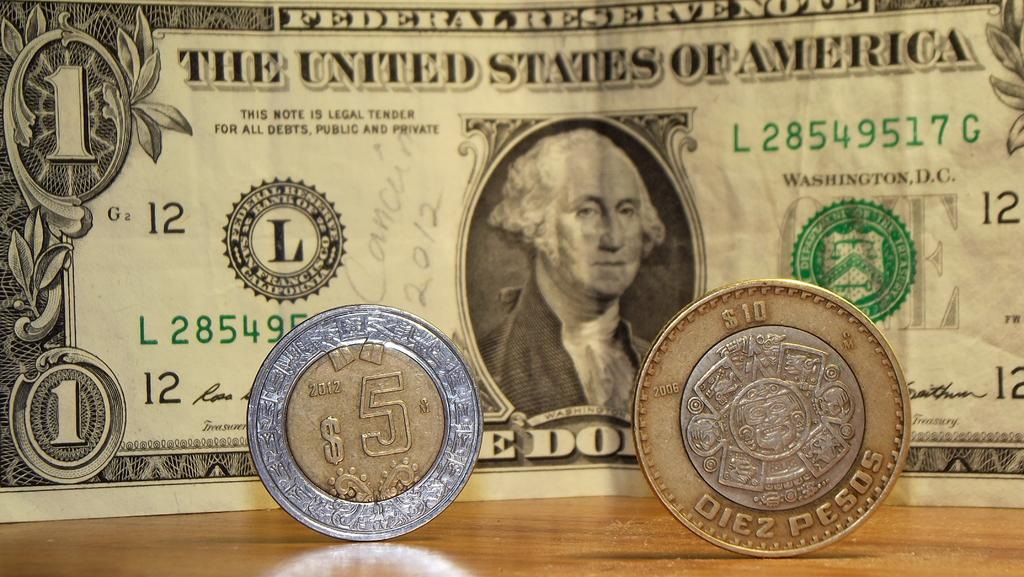Provide a one-sentence caption for the provided image. The $10 and $5 pesos coins are both smaller than the American dollar bill. 